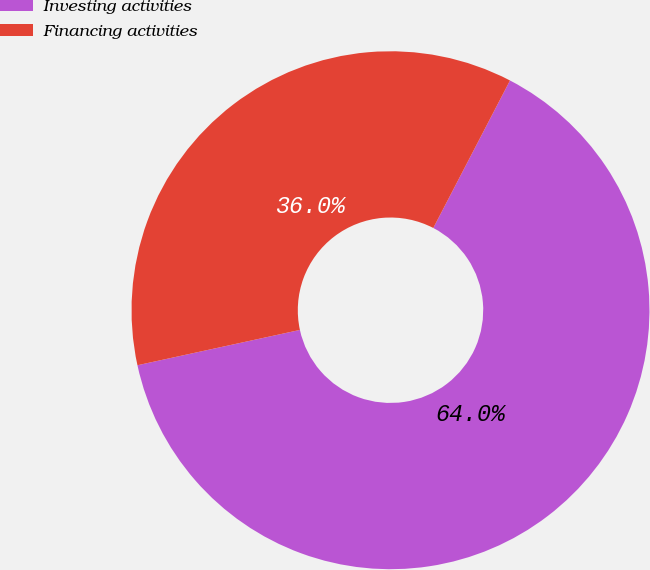Convert chart. <chart><loc_0><loc_0><loc_500><loc_500><pie_chart><fcel>Investing activities<fcel>Financing activities<nl><fcel>63.96%<fcel>36.04%<nl></chart> 